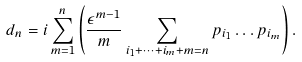<formula> <loc_0><loc_0><loc_500><loc_500>d _ { n } = i \sum _ { m = 1 } ^ { n } \left ( \frac { \epsilon ^ { m - 1 } } { m } \sum _ { i _ { 1 } + \cdots + i _ { m } + m = n } p _ { i _ { 1 } } \dots p _ { i _ { m } } \right ) .</formula> 